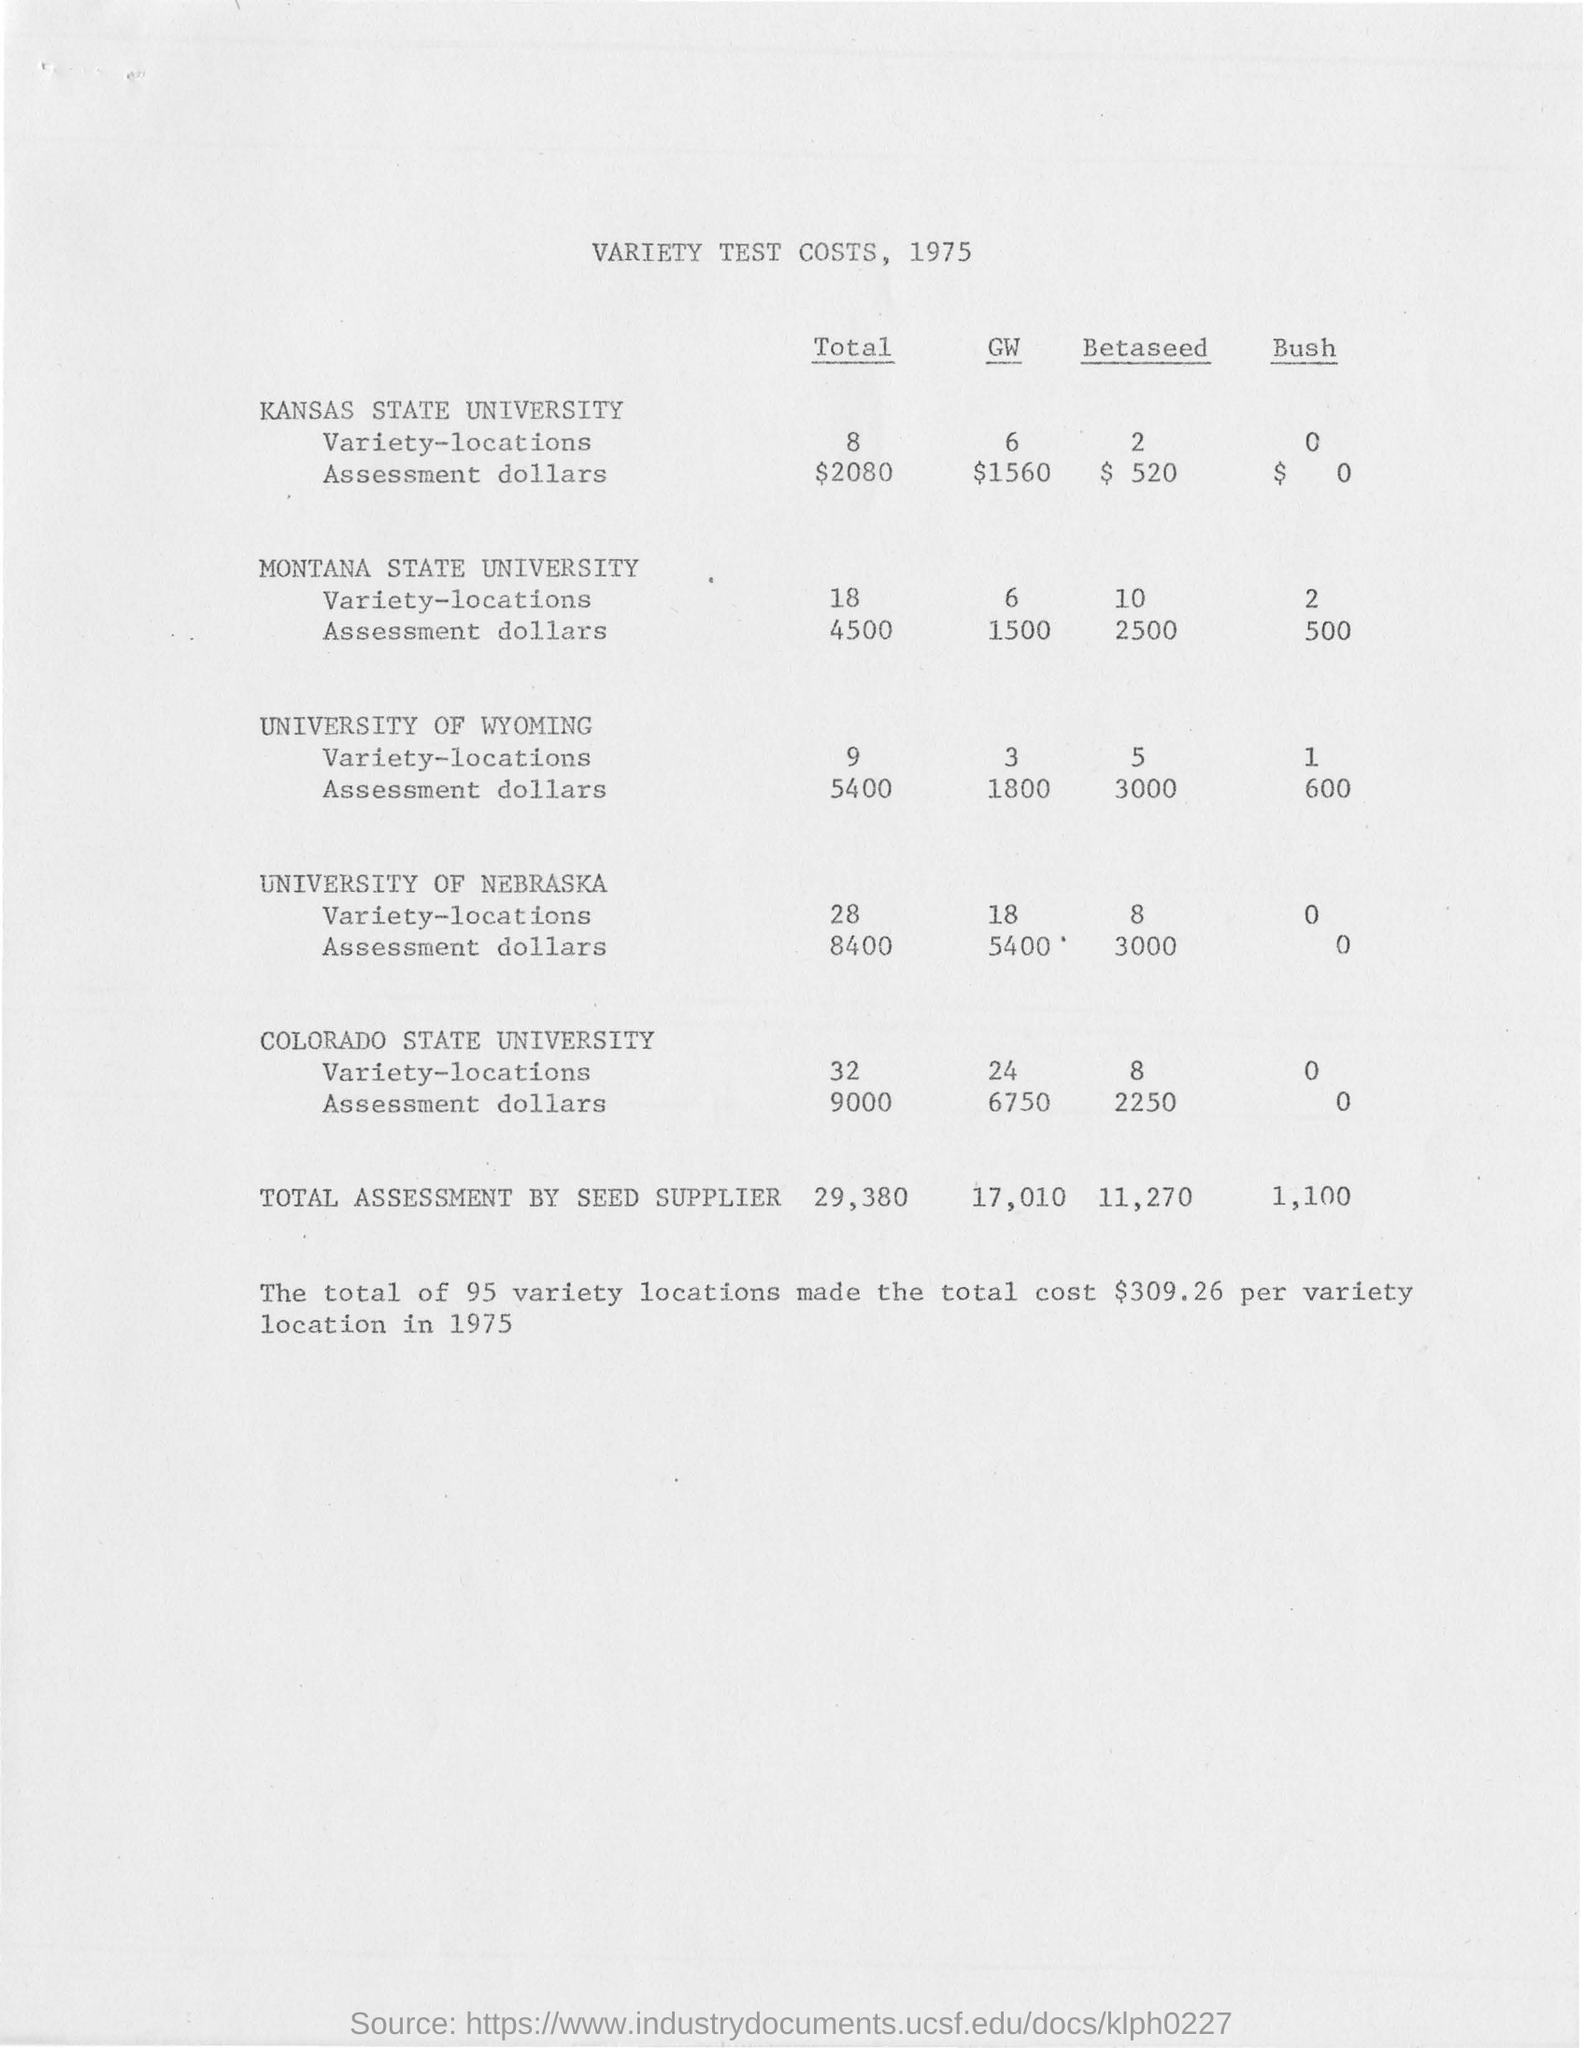What is the year of this document?
Keep it short and to the point. 1975. What is the total amount variety locations for Kansas State University?
Provide a succinct answer. 8. What is the total assessment amount by seed supplier?
Provide a short and direct response. 29,380. What is the total number of variety locations?
Your answer should be compact. 95. What is the total cost per variety location in 1975?
Offer a very short reply. $309.26. 